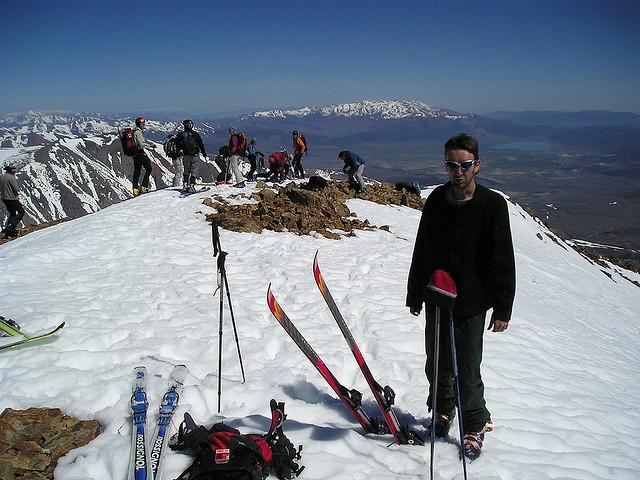Is he looking at the camera?
Quick response, please. Yes. Are the people skiing?
Write a very short answer. Yes. How many pairs of skies are in the picture?
Be succinct. 2. Did the people ski to the top?
Write a very short answer. No. 